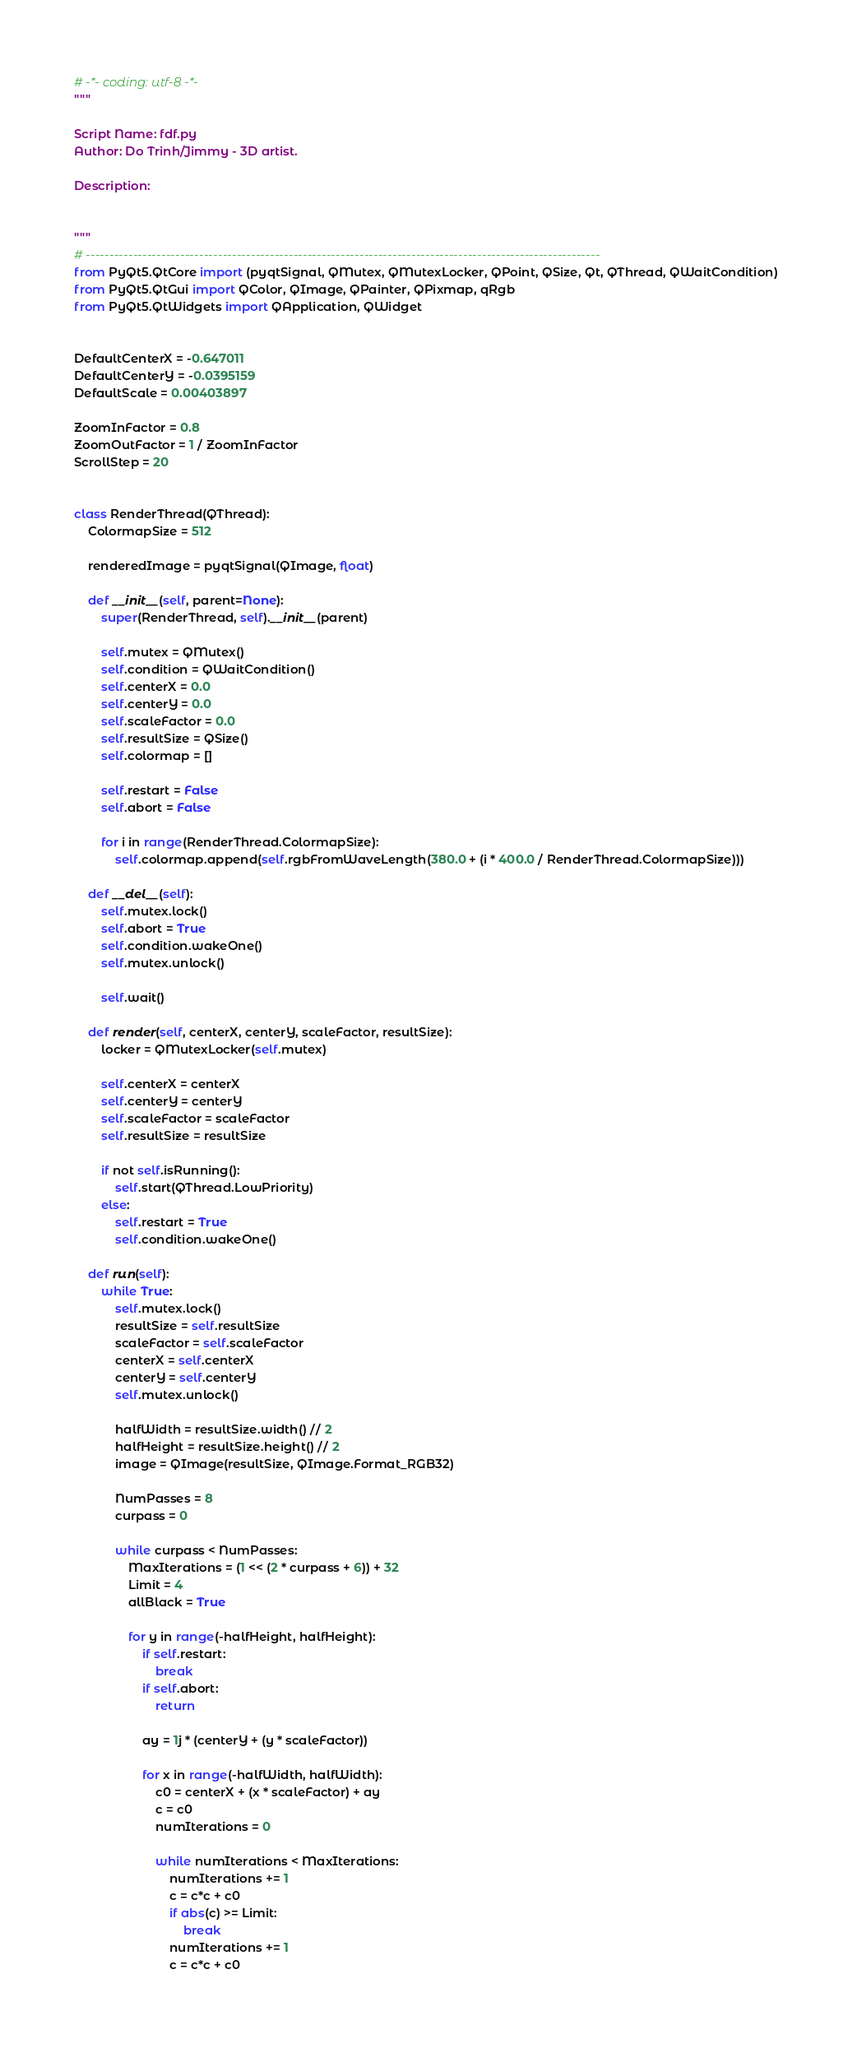Convert code to text. <code><loc_0><loc_0><loc_500><loc_500><_Python_># -*- coding: utf-8 -*-
"""

Script Name: fdf.py
Author: Do Trinh/Jimmy - 3D artist.

Description:
    

"""
# -------------------------------------------------------------------------------------------------------------
from PyQt5.QtCore import (pyqtSignal, QMutex, QMutexLocker, QPoint, QSize, Qt, QThread, QWaitCondition)
from PyQt5.QtGui import QColor, QImage, QPainter, QPixmap, qRgb
from PyQt5.QtWidgets import QApplication, QWidget


DefaultCenterX = -0.647011
DefaultCenterY = -0.0395159
DefaultScale = 0.00403897

ZoomInFactor = 0.8
ZoomOutFactor = 1 / ZoomInFactor
ScrollStep = 20


class RenderThread(QThread):
    ColormapSize = 512

    renderedImage = pyqtSignal(QImage, float)

    def __init__(self, parent=None):
        super(RenderThread, self).__init__(parent)

        self.mutex = QMutex()
        self.condition = QWaitCondition()
        self.centerX = 0.0
        self.centerY = 0.0
        self.scaleFactor = 0.0
        self.resultSize = QSize()
        self.colormap = []

        self.restart = False
        self.abort = False

        for i in range(RenderThread.ColormapSize):
            self.colormap.append(self.rgbFromWaveLength(380.0 + (i * 400.0 / RenderThread.ColormapSize)))

    def __del__(self):
        self.mutex.lock()
        self.abort = True
        self.condition.wakeOne()
        self.mutex.unlock()

        self.wait()

    def render(self, centerX, centerY, scaleFactor, resultSize):
        locker = QMutexLocker(self.mutex)

        self.centerX = centerX
        self.centerY = centerY
        self.scaleFactor = scaleFactor
        self.resultSize = resultSize

        if not self.isRunning():
            self.start(QThread.LowPriority)
        else:
            self.restart = True
            self.condition.wakeOne()

    def run(self):
        while True:
            self.mutex.lock()
            resultSize = self.resultSize
            scaleFactor = self.scaleFactor
            centerX = self.centerX
            centerY = self.centerY
            self.mutex.unlock()

            halfWidth = resultSize.width() // 2
            halfHeight = resultSize.height() // 2
            image = QImage(resultSize, QImage.Format_RGB32)

            NumPasses = 8
            curpass = 0

            while curpass < NumPasses:
                MaxIterations = (1 << (2 * curpass + 6)) + 32
                Limit = 4
                allBlack = True

                for y in range(-halfHeight, halfHeight):
                    if self.restart:
                        break
                    if self.abort:
                        return

                    ay = 1j * (centerY + (y * scaleFactor))

                    for x in range(-halfWidth, halfWidth):
                        c0 = centerX + (x * scaleFactor) + ay
                        c = c0
                        numIterations = 0

                        while numIterations < MaxIterations:
                            numIterations += 1
                            c = c*c + c0
                            if abs(c) >= Limit:
                                break
                            numIterations += 1
                            c = c*c + c0</code> 